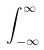Convert formula to latex. <formula><loc_0><loc_0><loc_500><loc_500>\int _ { - \infty } ^ { \infty }</formula> 